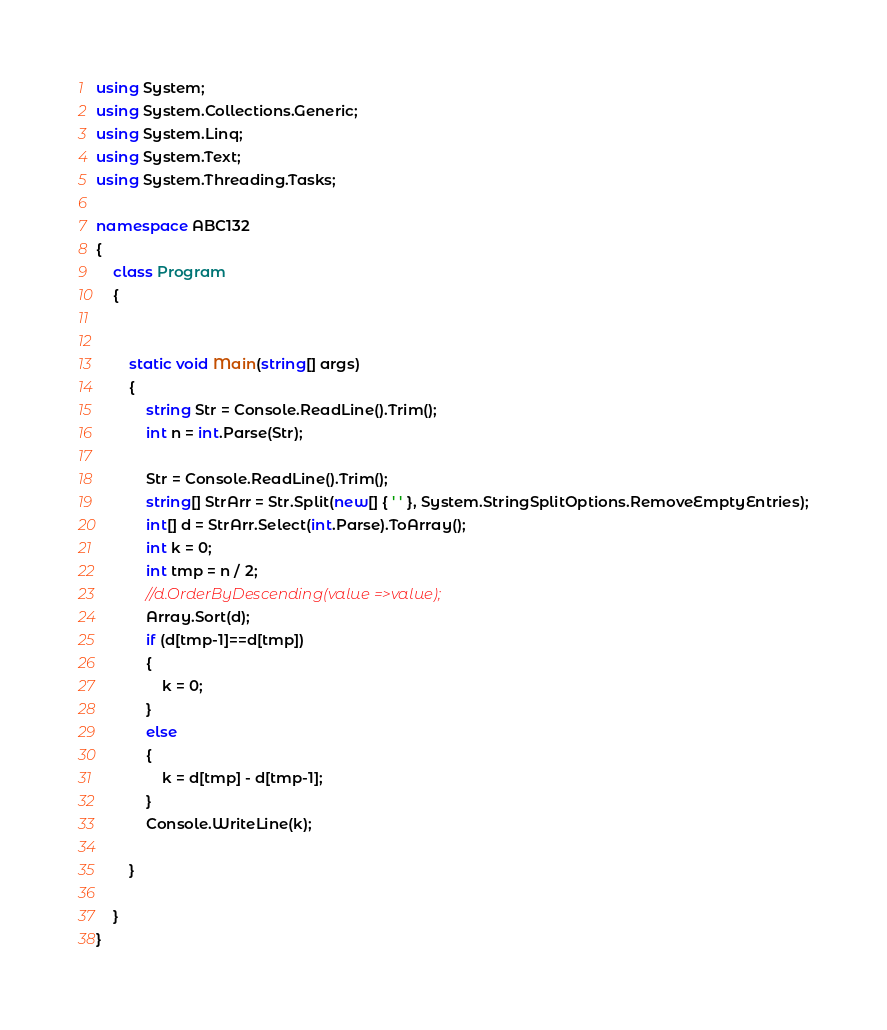Convert code to text. <code><loc_0><loc_0><loc_500><loc_500><_C#_>using System;
using System.Collections.Generic;
using System.Linq;
using System.Text;
using System.Threading.Tasks;

namespace ABC132
{
    class Program
    {


        static void Main(string[] args)
        {
            string Str = Console.ReadLine().Trim();
            int n = int.Parse(Str);

            Str = Console.ReadLine().Trim();
            string[] StrArr = Str.Split(new[] { ' ' }, System.StringSplitOptions.RemoveEmptyEntries);
            int[] d = StrArr.Select(int.Parse).ToArray();
            int k = 0;
            int tmp = n / 2;
            //d.OrderByDescending(value =>value);
            Array.Sort(d);
            if (d[tmp-1]==d[tmp])
            {
                k = 0;
            }
            else
            {
                k = d[tmp] - d[tmp-1];
            }
            Console.WriteLine(k);

        }

    }
}
</code> 